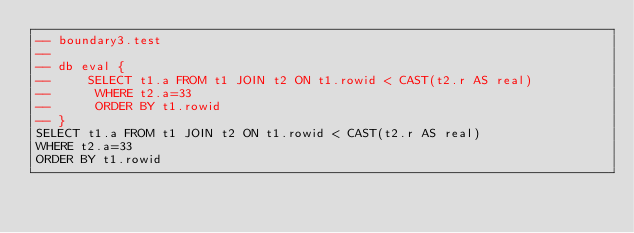Convert code to text. <code><loc_0><loc_0><loc_500><loc_500><_SQL_>-- boundary3.test
-- 
-- db eval {
--     SELECT t1.a FROM t1 JOIN t2 ON t1.rowid < CAST(t2.r AS real)
--      WHERE t2.a=33
--      ORDER BY t1.rowid
-- }
SELECT t1.a FROM t1 JOIN t2 ON t1.rowid < CAST(t2.r AS real)
WHERE t2.a=33
ORDER BY t1.rowid</code> 